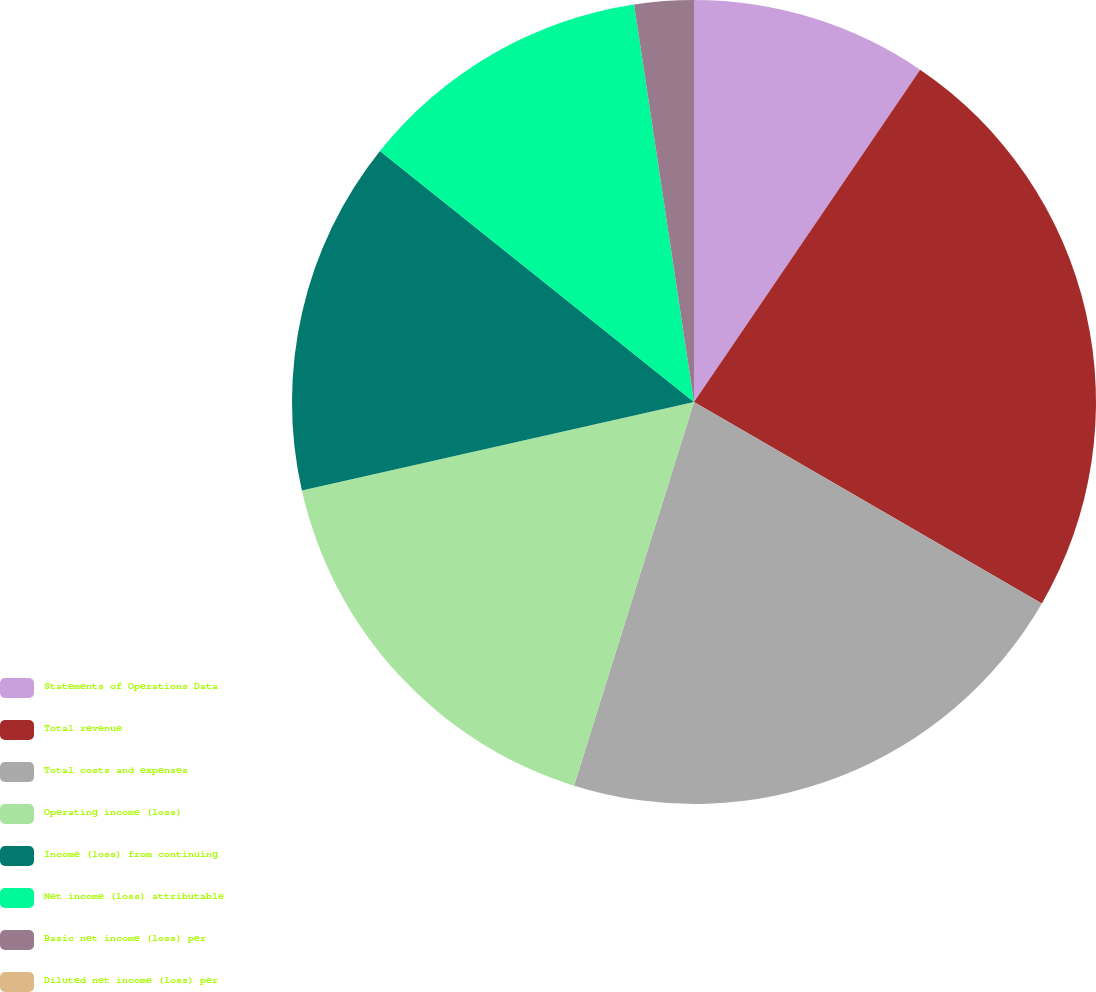Convert chart. <chart><loc_0><loc_0><loc_500><loc_500><pie_chart><fcel>Statements of Operations Data<fcel>Total revenue<fcel>Total costs and expenses<fcel>Operating income (loss)<fcel>Income (loss) from continuing<fcel>Net income (loss) attributable<fcel>Basic net income (loss) per<fcel>Diluted net income (loss) per<nl><fcel>9.51%<fcel>23.85%<fcel>21.47%<fcel>16.64%<fcel>14.27%<fcel>11.89%<fcel>2.38%<fcel>0.0%<nl></chart> 